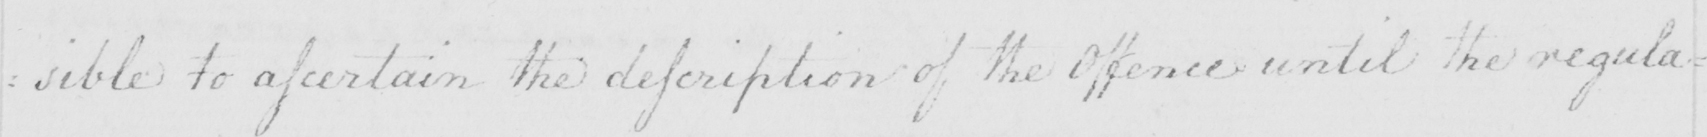Can you tell me what this handwritten text says? : sible to ascertain the description of the Offence until the regula- 